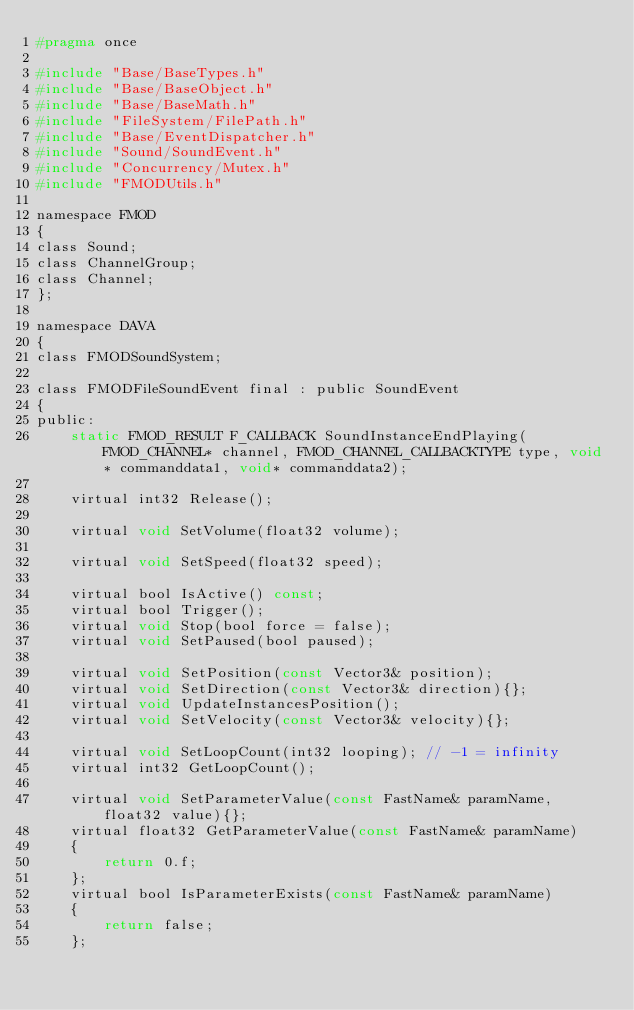<code> <loc_0><loc_0><loc_500><loc_500><_C_>#pragma once

#include "Base/BaseTypes.h"
#include "Base/BaseObject.h"
#include "Base/BaseMath.h"
#include "FileSystem/FilePath.h"
#include "Base/EventDispatcher.h"
#include "Sound/SoundEvent.h"
#include "Concurrency/Mutex.h"
#include "FMODUtils.h"

namespace FMOD
{
class Sound;
class ChannelGroup;
class Channel;
};

namespace DAVA
{
class FMODSoundSystem;

class FMODFileSoundEvent final : public SoundEvent
{
public:
    static FMOD_RESULT F_CALLBACK SoundInstanceEndPlaying(FMOD_CHANNEL* channel, FMOD_CHANNEL_CALLBACKTYPE type, void* commanddata1, void* commanddata2);

    virtual int32 Release();

    virtual void SetVolume(float32 volume);

    virtual void SetSpeed(float32 speed);

    virtual bool IsActive() const;
    virtual bool Trigger();
    virtual void Stop(bool force = false);
    virtual void SetPaused(bool paused);

    virtual void SetPosition(const Vector3& position);
    virtual void SetDirection(const Vector3& direction){};
    virtual void UpdateInstancesPosition();
    virtual void SetVelocity(const Vector3& velocity){};

    virtual void SetLoopCount(int32 looping); // -1 = infinity
    virtual int32 GetLoopCount();

    virtual void SetParameterValue(const FastName& paramName, float32 value){};
    virtual float32 GetParameterValue(const FastName& paramName)
    {
        return 0.f;
    };
    virtual bool IsParameterExists(const FastName& paramName)
    {
        return false;
    };
</code> 